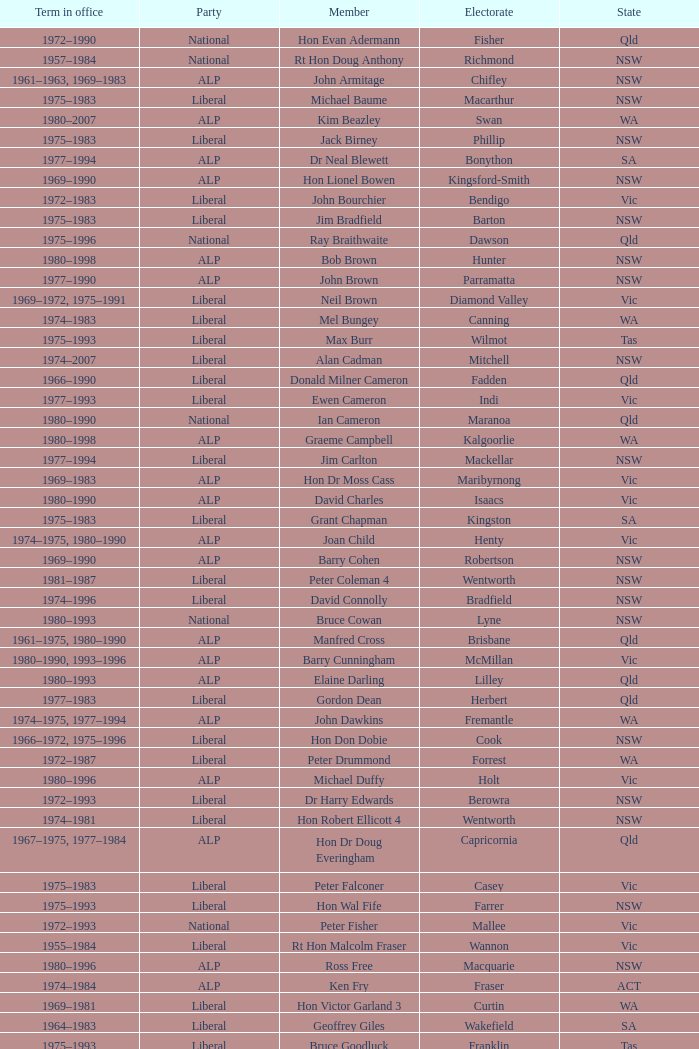What party is Mick Young a member of? ALP. 